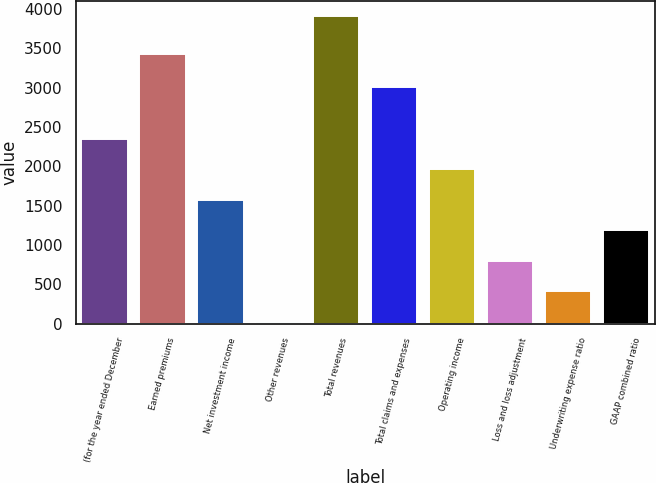Convert chart to OTSL. <chart><loc_0><loc_0><loc_500><loc_500><bar_chart><fcel>(for the year ended December<fcel>Earned premiums<fcel>Net investment income<fcel>Other revenues<fcel>Total revenues<fcel>Total claims and expenses<fcel>Operating income<fcel>Loss and loss adjustment<fcel>Underwriting expense ratio<fcel>GAAP combined ratio<nl><fcel>2353.8<fcel>3429<fcel>1577.2<fcel>24<fcel>3907<fcel>3004<fcel>1965.5<fcel>800.6<fcel>412.3<fcel>1188.9<nl></chart> 